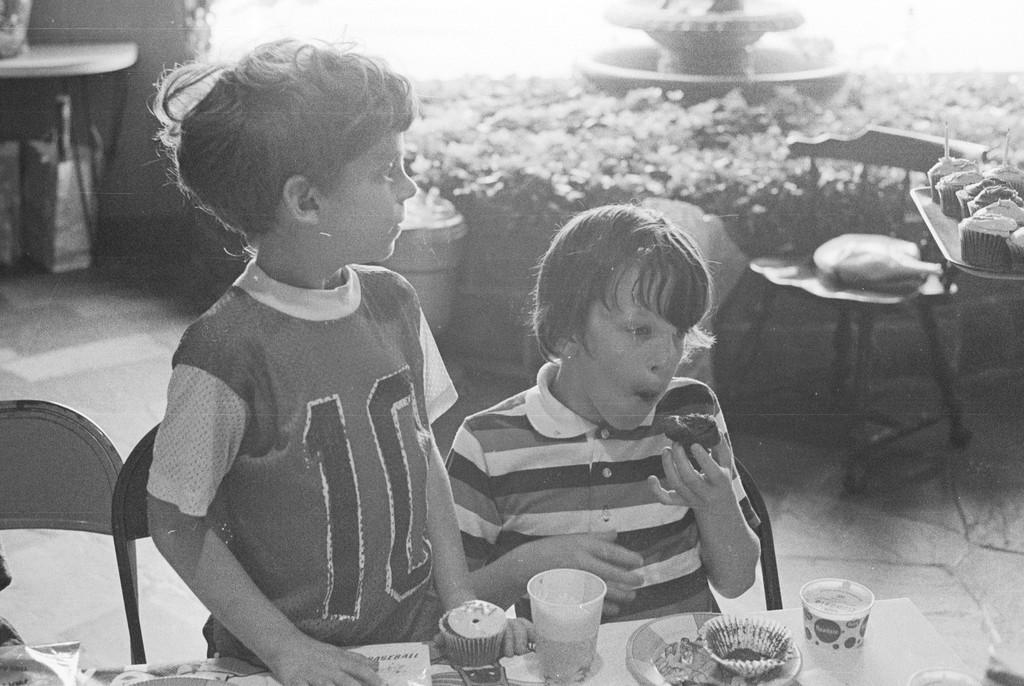What type of objects can be seen in the image? There are plants, tables, chairs, plates, and glasses visible in the image. How many people are present in the image? There are two people in the image. What might the people be using the tables and chairs for? The tables and chairs suggest that the people might be sitting down for a meal or gathering. What is on the table that might be used for eating or drinking? There are plates and glasses on the table. What type of mark can be seen on the quartz in the image? There is no quartz present in the image, and therefore no mark can be observed. 